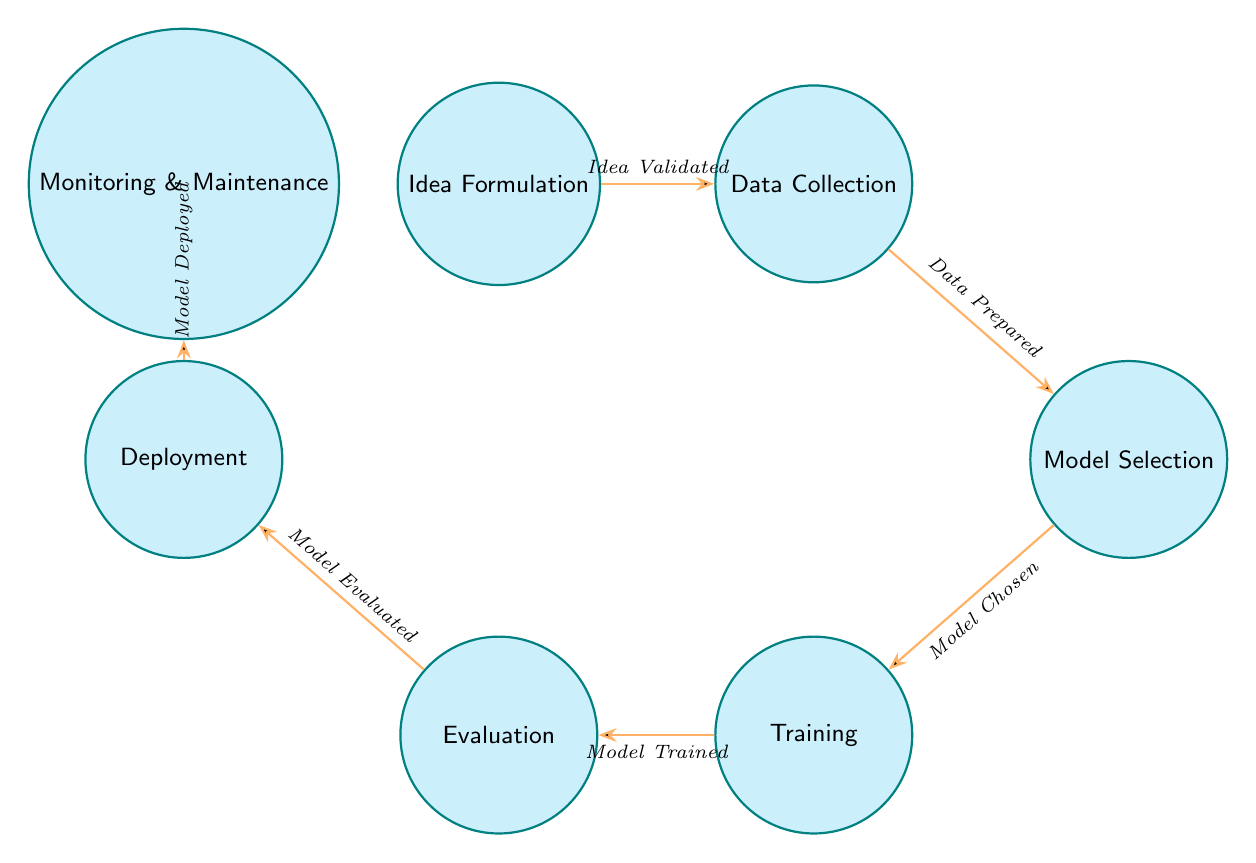What is the first state in the diagram? The first state specified in the data is "Idea Formulation," which is the initial step in the AI research experiment lifecycle depicted in the diagram.
Answer: Idea Formulation How many states are there in total? The data includes seven distinct states, each representing a different phase of the AI research experiment lifecycle.
Answer: 7 What is the transition trigger from "Training" to "Evaluation"? According to the transitions provided, the transition from "Training" to "Evaluation" occurs when the "Model Trained" trigger is activated.
Answer: Model Trained Which state follows "Evaluation"? The state that follows "Evaluation" in the sequence of the diagram is "Deployment," indicating the step that comes after evaluating the models.
Answer: Deployment What is the relationship between "Data Collection" and "Model Selection"? The relationship indicates that after the data has been prepared in the "Data Collection" state, the next step is to proceed to "Model Selection," which is triggered by the completion of data preparation.
Answer: Data Prepared What is the last state in the diagram? The final state in the transition sequence is "Monitoring and Maintenance," which is the last phase after the model has been deployed.
Answer: Monitoring and Maintenance Which state initiates the AI research experiment lifecycle? The AI research experiment lifecycle initiates with "Idea Formulation," where the research idea is first developed.
Answer: Idea Formulation 